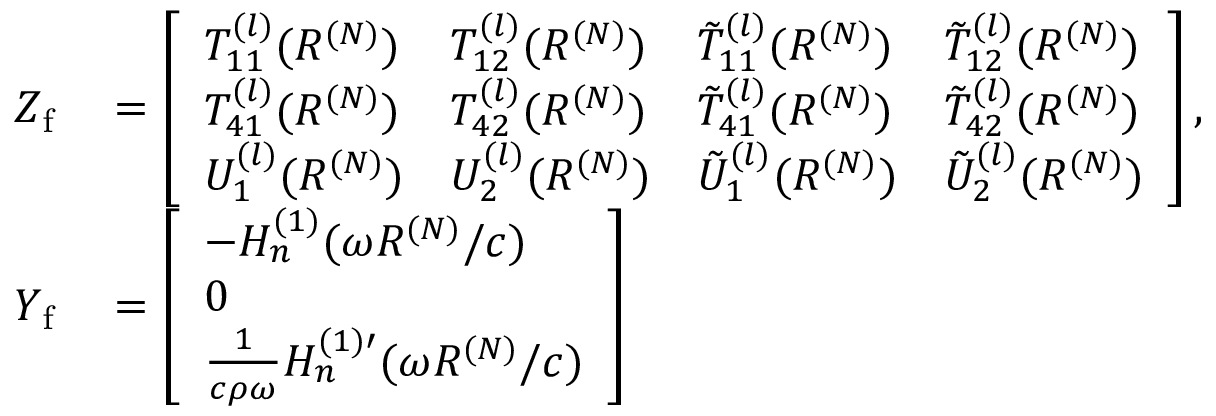<formula> <loc_0><loc_0><loc_500><loc_500>\begin{array} { r l } { Z _ { f } } & = \left [ \begin{array} { l l l l } { T _ { 1 1 } ^ { ( l ) } ( R ^ { ( N ) } ) } & { T _ { 1 2 } ^ { ( l ) } ( R ^ { ( N ) } ) } & { \tilde { T } _ { 1 1 } ^ { ( l ) } ( R ^ { ( N ) } ) } & { \tilde { T } _ { 1 2 } ^ { ( l ) } ( R ^ { ( N ) } ) } \\ { T _ { 4 1 } ^ { ( l ) } ( R ^ { ( N ) } ) } & { T _ { 4 2 } ^ { ( l ) } ( R ^ { ( N ) } ) } & { \tilde { T } _ { 4 1 } ^ { ( l ) } ( R ^ { ( N ) } ) } & { \tilde { T } _ { 4 2 } ^ { ( l ) } ( R ^ { ( N ) } ) } \\ { U _ { 1 } ^ { ( l ) } ( R ^ { ( N ) } ) } & { U _ { 2 } ^ { ( l ) } ( R ^ { ( N ) } ) } & { \tilde { U } _ { 1 } ^ { ( l ) } ( R ^ { ( N ) } ) } & { \tilde { U } _ { 2 } ^ { ( l ) } ( R ^ { ( N ) } ) } \end{array} \right ] , } \\ { Y _ { f } } & = \left [ \begin{array} { l } { - H _ { n } ^ { ( 1 ) } ( \omega R ^ { ( N ) } / c ) } \\ { 0 } \\ { \frac { 1 } { c \rho \omega } H _ { n } ^ { ( 1 ) \prime } ( \omega R ^ { ( N ) } / c ) } \end{array} \right ] } \end{array}</formula> 